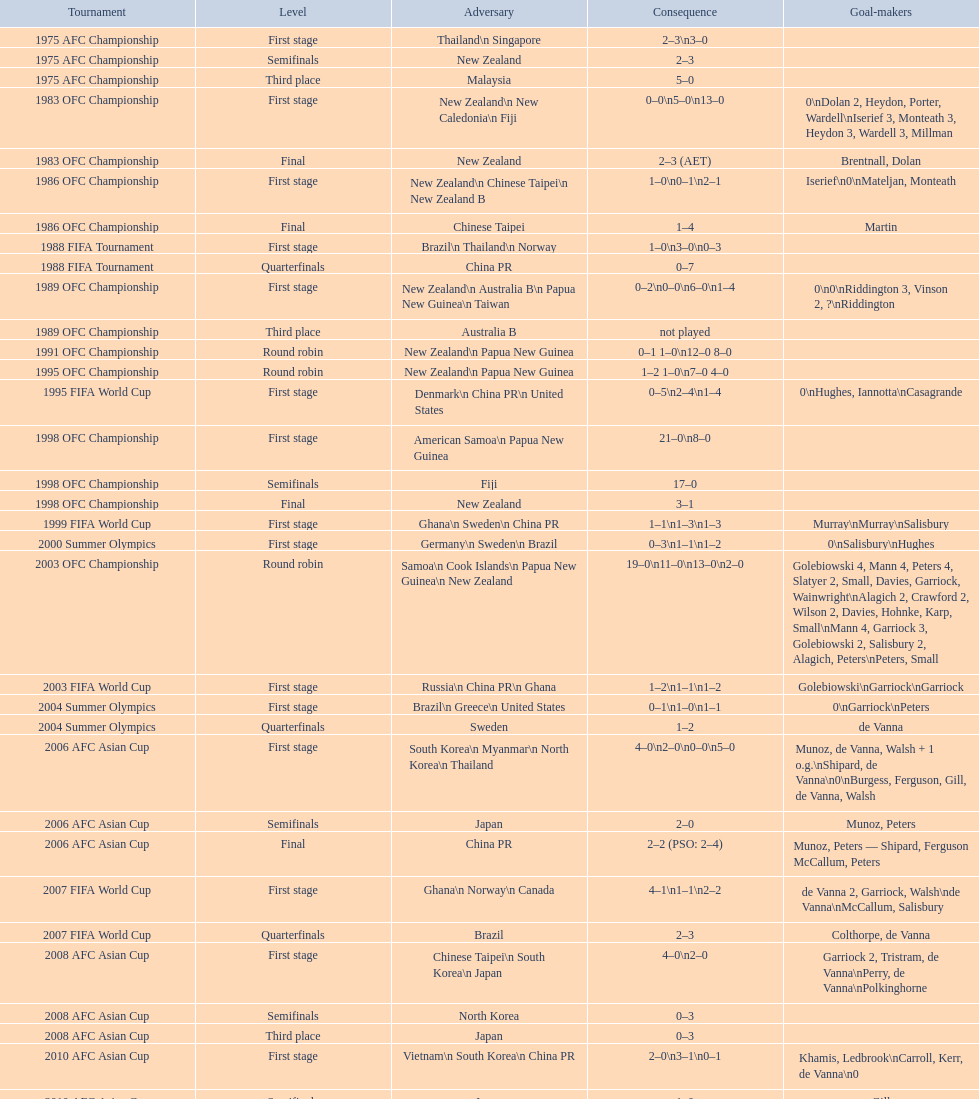Can you give me this table as a dict? {'header': ['Tournament', 'Level', 'Adversary', 'Consequence', 'Goal-makers'], 'rows': [['1975 AFC Championship', 'First stage', 'Thailand\\n\xa0Singapore', '2–3\\n3–0', ''], ['1975 AFC Championship', 'Semifinals', 'New Zealand', '2–3', ''], ['1975 AFC Championship', 'Third place', 'Malaysia', '5–0', ''], ['1983 OFC Championship', 'First stage', 'New Zealand\\n\xa0New Caledonia\\n\xa0Fiji', '0–0\\n5–0\\n13–0', '0\\nDolan 2, Heydon, Porter, Wardell\\nIserief 3, Monteath 3, Heydon 3, Wardell 3, Millman'], ['1983 OFC Championship', 'Final', 'New Zealand', '2–3 (AET)', 'Brentnall, Dolan'], ['1986 OFC Championship', 'First stage', 'New Zealand\\n\xa0Chinese Taipei\\n New Zealand B', '1–0\\n0–1\\n2–1', 'Iserief\\n0\\nMateljan, Monteath'], ['1986 OFC Championship', 'Final', 'Chinese Taipei', '1–4', 'Martin'], ['1988 FIFA Tournament', 'First stage', 'Brazil\\n\xa0Thailand\\n\xa0Norway', '1–0\\n3–0\\n0–3', ''], ['1988 FIFA Tournament', 'Quarterfinals', 'China PR', '0–7', ''], ['1989 OFC Championship', 'First stage', 'New Zealand\\n Australia B\\n\xa0Papua New Guinea\\n\xa0Taiwan', '0–2\\n0–0\\n6–0\\n1–4', '0\\n0\\nRiddington 3, Vinson 2,\xa0?\\nRiddington'], ['1989 OFC Championship', 'Third place', 'Australia B', 'not played', ''], ['1991 OFC Championship', 'Round robin', 'New Zealand\\n\xa0Papua New Guinea', '0–1 1–0\\n12–0 8–0', ''], ['1995 OFC Championship', 'Round robin', 'New Zealand\\n\xa0Papua New Guinea', '1–2 1–0\\n7–0 4–0', ''], ['1995 FIFA World Cup', 'First stage', 'Denmark\\n\xa0China PR\\n\xa0United States', '0–5\\n2–4\\n1–4', '0\\nHughes, Iannotta\\nCasagrande'], ['1998 OFC Championship', 'First stage', 'American Samoa\\n\xa0Papua New Guinea', '21–0\\n8–0', ''], ['1998 OFC Championship', 'Semifinals', 'Fiji', '17–0', ''], ['1998 OFC Championship', 'Final', 'New Zealand', '3–1', ''], ['1999 FIFA World Cup', 'First stage', 'Ghana\\n\xa0Sweden\\n\xa0China PR', '1–1\\n1–3\\n1–3', 'Murray\\nMurray\\nSalisbury'], ['2000 Summer Olympics', 'First stage', 'Germany\\n\xa0Sweden\\n\xa0Brazil', '0–3\\n1–1\\n1–2', '0\\nSalisbury\\nHughes'], ['2003 OFC Championship', 'Round robin', 'Samoa\\n\xa0Cook Islands\\n\xa0Papua New Guinea\\n\xa0New Zealand', '19–0\\n11–0\\n13–0\\n2–0', 'Golebiowski 4, Mann 4, Peters 4, Slatyer 2, Small, Davies, Garriock, Wainwright\\nAlagich 2, Crawford 2, Wilson 2, Davies, Hohnke, Karp, Small\\nMann 4, Garriock 3, Golebiowski 2, Salisbury 2, Alagich, Peters\\nPeters, Small'], ['2003 FIFA World Cup', 'First stage', 'Russia\\n\xa0China PR\\n\xa0Ghana', '1–2\\n1–1\\n1–2', 'Golebiowski\\nGarriock\\nGarriock'], ['2004 Summer Olympics', 'First stage', 'Brazil\\n\xa0Greece\\n\xa0United States', '0–1\\n1–0\\n1–1', '0\\nGarriock\\nPeters'], ['2004 Summer Olympics', 'Quarterfinals', 'Sweden', '1–2', 'de Vanna'], ['2006 AFC Asian Cup', 'First stage', 'South Korea\\n\xa0Myanmar\\n\xa0North Korea\\n\xa0Thailand', '4–0\\n2–0\\n0–0\\n5–0', 'Munoz, de Vanna, Walsh + 1 o.g.\\nShipard, de Vanna\\n0\\nBurgess, Ferguson, Gill, de Vanna, Walsh'], ['2006 AFC Asian Cup', 'Semifinals', 'Japan', '2–0', 'Munoz, Peters'], ['2006 AFC Asian Cup', 'Final', 'China PR', '2–2 (PSO: 2–4)', 'Munoz, Peters — Shipard, Ferguson McCallum, Peters'], ['2007 FIFA World Cup', 'First stage', 'Ghana\\n\xa0Norway\\n\xa0Canada', '4–1\\n1–1\\n2–2', 'de Vanna 2, Garriock, Walsh\\nde Vanna\\nMcCallum, Salisbury'], ['2007 FIFA World Cup', 'Quarterfinals', 'Brazil', '2–3', 'Colthorpe, de Vanna'], ['2008 AFC Asian Cup', 'First stage', 'Chinese Taipei\\n\xa0South Korea\\n\xa0Japan', '4–0\\n2–0', 'Garriock 2, Tristram, de Vanna\\nPerry, de Vanna\\nPolkinghorne'], ['2008 AFC Asian Cup', 'Semifinals', 'North Korea', '0–3', ''], ['2008 AFC Asian Cup', 'Third place', 'Japan', '0–3', ''], ['2010 AFC Asian Cup', 'First stage', 'Vietnam\\n\xa0South Korea\\n\xa0China PR', '2–0\\n3–1\\n0–1', 'Khamis, Ledbrook\\nCarroll, Kerr, de Vanna\\n0'], ['2010 AFC Asian Cup', 'Semifinals', 'Japan', '1–0', 'Gill'], ['2010 AFC Asian Cup', 'Final', 'North Korea', '1–1 (PSO: 5–4)', 'Kerr — PSO: Shipard, Ledbrook, Gill, Garriock, Simon'], ['2011 FIFA World Cup', 'First stage', 'Brazil\\n\xa0Equatorial Guinea\\n\xa0Norway', '0–1\\n3–2\\n2–1', '0\\nvan Egmond, Khamis, de Vanna\\nSimon 2'], ['2011 FIFA World Cup', 'Quarterfinals', 'Sweden', '1–3', 'Perry'], ['2012 Summer Olympics\\nAFC qualification', 'Final round', 'North Korea\\n\xa0Thailand\\n\xa0Japan\\n\xa0China PR\\n\xa0South Korea', '0–1\\n5–1\\n0–1\\n1–0\\n2–1', '0\\nHeyman 2, Butt, van Egmond, Simon\\n0\\nvan Egmond\\nButt, de Vanna'], ['2014 AFC Asian Cup', 'First stage', 'Japan\\n\xa0Jordan\\n\xa0Vietnam', 'TBD\\nTBD\\nTBD', '']]} Who was this squad's subsequent rival after encountering new zealand in the initial phase of the 1986 ofc championship? Chinese Taipei. 